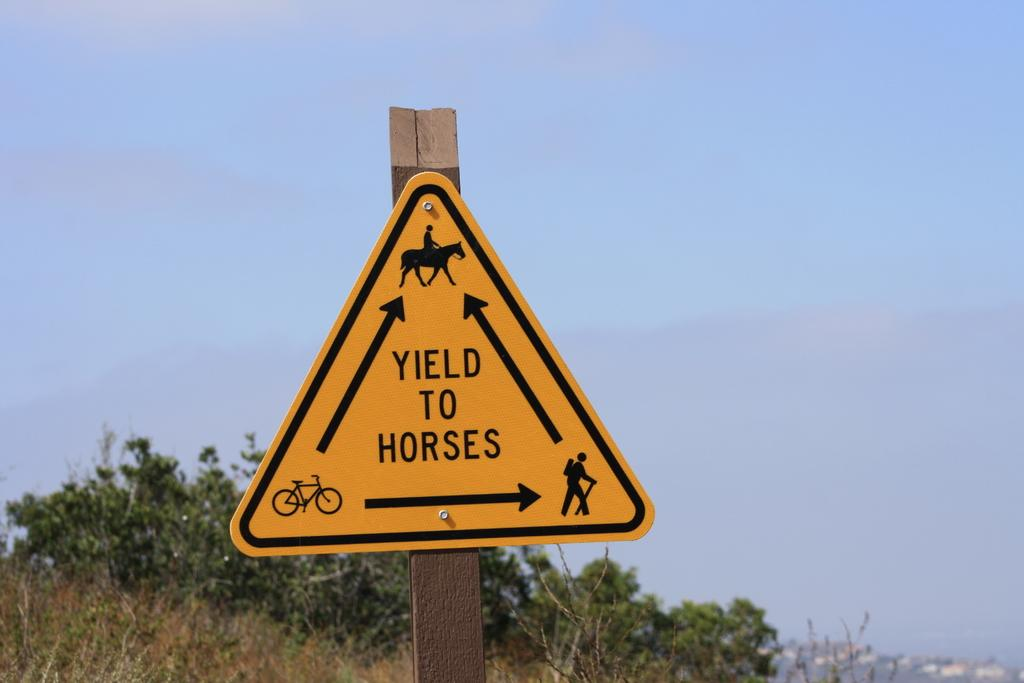<image>
Describe the image concisely. A yellow sign on the side of the road says yield to horses 